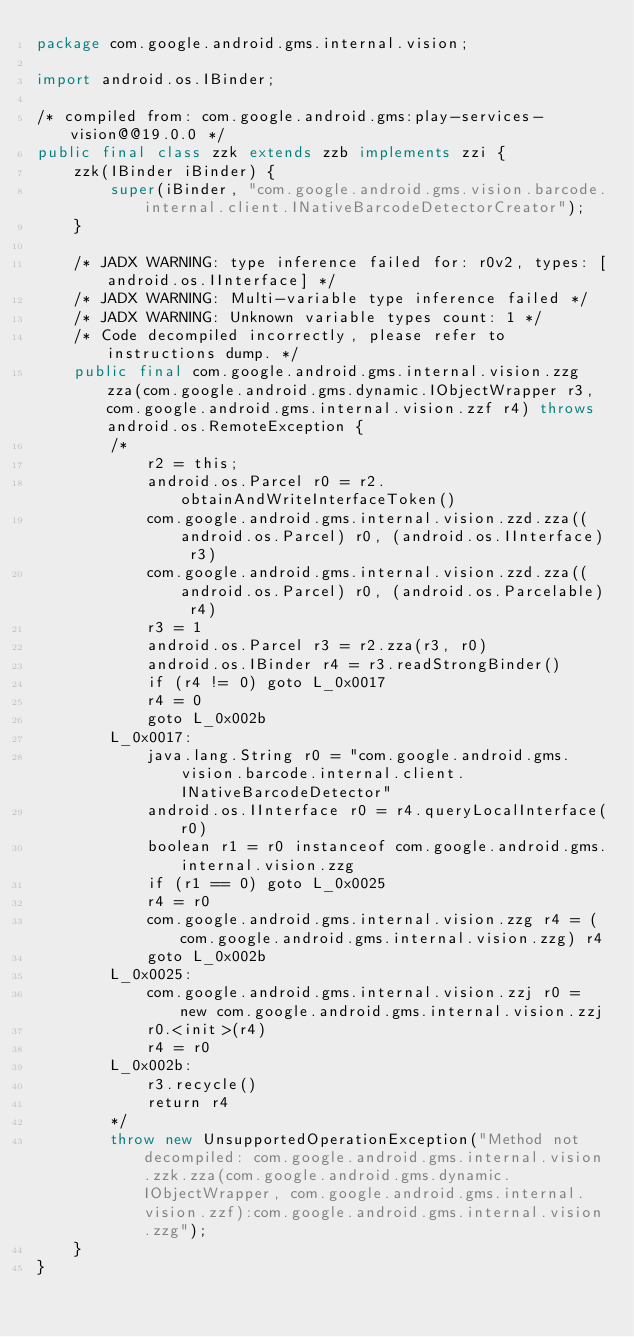<code> <loc_0><loc_0><loc_500><loc_500><_Java_>package com.google.android.gms.internal.vision;

import android.os.IBinder;

/* compiled from: com.google.android.gms:play-services-vision@@19.0.0 */
public final class zzk extends zzb implements zzi {
    zzk(IBinder iBinder) {
        super(iBinder, "com.google.android.gms.vision.barcode.internal.client.INativeBarcodeDetectorCreator");
    }

    /* JADX WARNING: type inference failed for: r0v2, types: [android.os.IInterface] */
    /* JADX WARNING: Multi-variable type inference failed */
    /* JADX WARNING: Unknown variable types count: 1 */
    /* Code decompiled incorrectly, please refer to instructions dump. */
    public final com.google.android.gms.internal.vision.zzg zza(com.google.android.gms.dynamic.IObjectWrapper r3, com.google.android.gms.internal.vision.zzf r4) throws android.os.RemoteException {
        /*
            r2 = this;
            android.os.Parcel r0 = r2.obtainAndWriteInterfaceToken()
            com.google.android.gms.internal.vision.zzd.zza((android.os.Parcel) r0, (android.os.IInterface) r3)
            com.google.android.gms.internal.vision.zzd.zza((android.os.Parcel) r0, (android.os.Parcelable) r4)
            r3 = 1
            android.os.Parcel r3 = r2.zza(r3, r0)
            android.os.IBinder r4 = r3.readStrongBinder()
            if (r4 != 0) goto L_0x0017
            r4 = 0
            goto L_0x002b
        L_0x0017:
            java.lang.String r0 = "com.google.android.gms.vision.barcode.internal.client.INativeBarcodeDetector"
            android.os.IInterface r0 = r4.queryLocalInterface(r0)
            boolean r1 = r0 instanceof com.google.android.gms.internal.vision.zzg
            if (r1 == 0) goto L_0x0025
            r4 = r0
            com.google.android.gms.internal.vision.zzg r4 = (com.google.android.gms.internal.vision.zzg) r4
            goto L_0x002b
        L_0x0025:
            com.google.android.gms.internal.vision.zzj r0 = new com.google.android.gms.internal.vision.zzj
            r0.<init>(r4)
            r4 = r0
        L_0x002b:
            r3.recycle()
            return r4
        */
        throw new UnsupportedOperationException("Method not decompiled: com.google.android.gms.internal.vision.zzk.zza(com.google.android.gms.dynamic.IObjectWrapper, com.google.android.gms.internal.vision.zzf):com.google.android.gms.internal.vision.zzg");
    }
}
</code> 